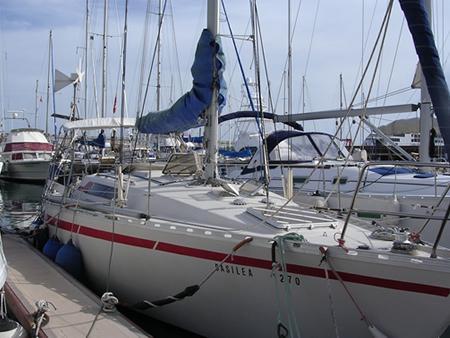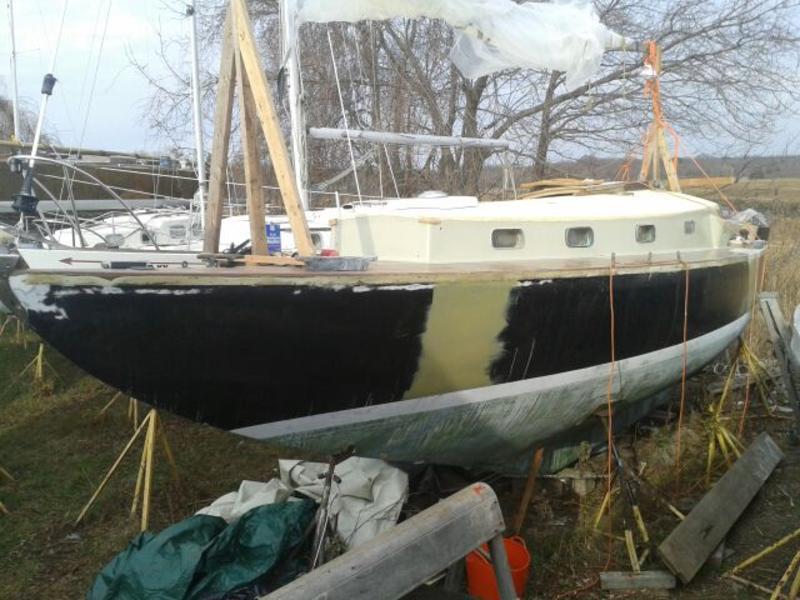The first image is the image on the left, the second image is the image on the right. For the images displayed, is the sentence "A boat in the right image is out of the water." factually correct? Answer yes or no. Yes. The first image is the image on the left, the second image is the image on the right. Assess this claim about the two images: "The left and right image contains the same number of sailboats.". Correct or not? Answer yes or no. No. 